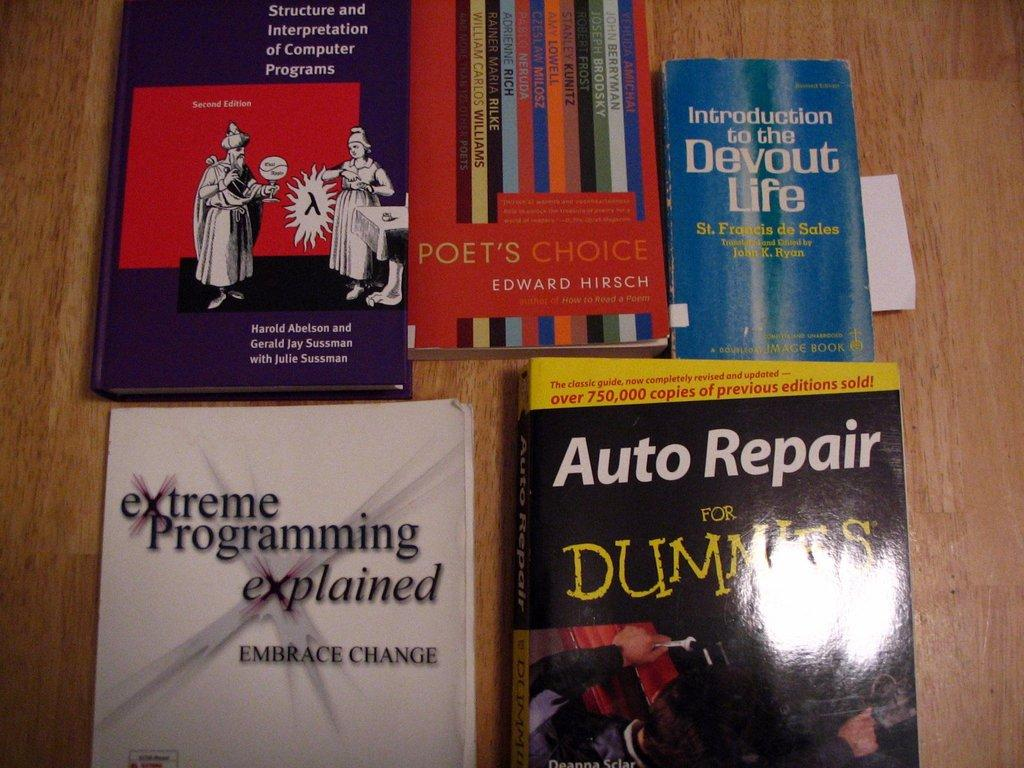<image>
Create a compact narrative representing the image presented. Books on a table include Auto Repair for Dummies 